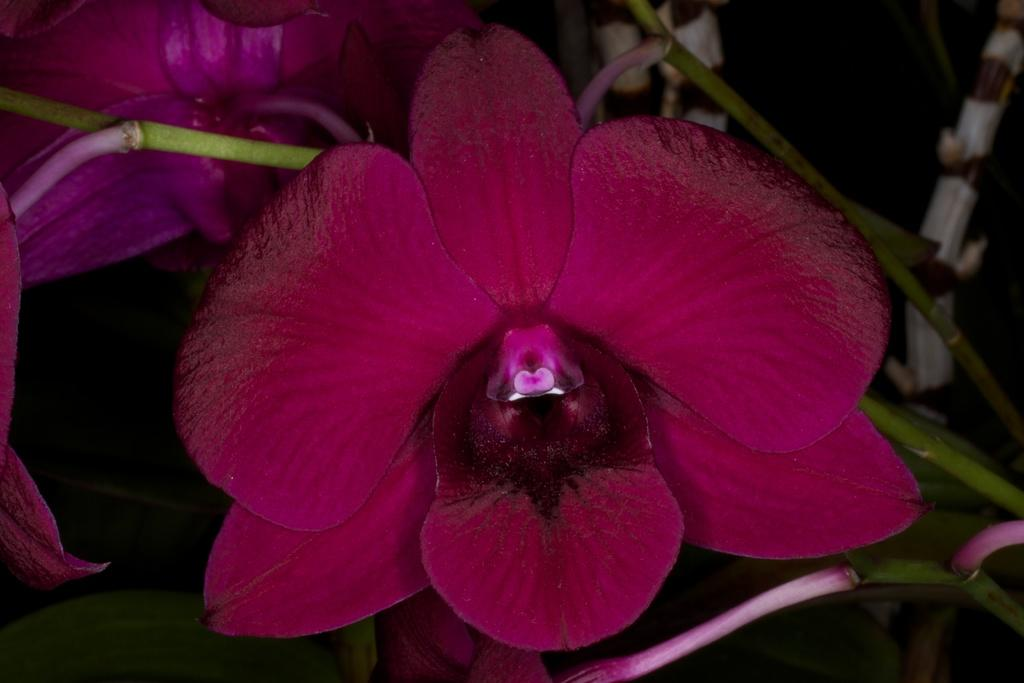What type of plants can be seen in the image? There are flowers in the image. What part of the flowers is visible in the image? There are stems in the image. How many railway tracks can be seen running through the flowers in the image? There are no railway tracks present in the image; it only features flowers and stems. What is the amount of sidewalk visible in the image? There is no sidewalk present in the image; it only features flowers and stems. 